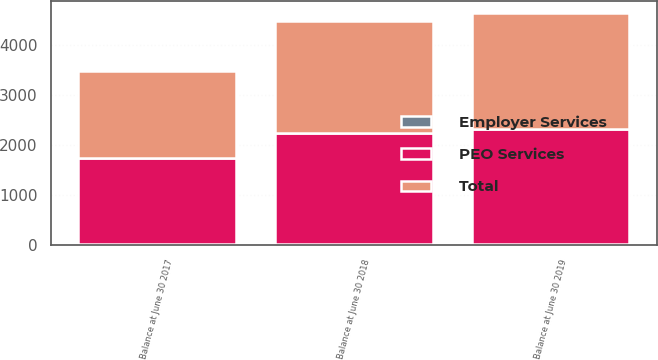Convert chart to OTSL. <chart><loc_0><loc_0><loc_500><loc_500><stacked_bar_chart><ecel><fcel>Balance at June 30 2017<fcel>Balance at June 30 2018<fcel>Balance at June 30 2019<nl><fcel>PEO Services<fcel>1736.2<fcel>2238.7<fcel>2318.2<nl><fcel>Employer Services<fcel>4.8<fcel>4.8<fcel>4.8<nl><fcel>Total<fcel>1741<fcel>2243.5<fcel>2323<nl></chart> 